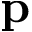<formula> <loc_0><loc_0><loc_500><loc_500>p</formula> 